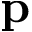<formula> <loc_0><loc_0><loc_500><loc_500>p</formula> 